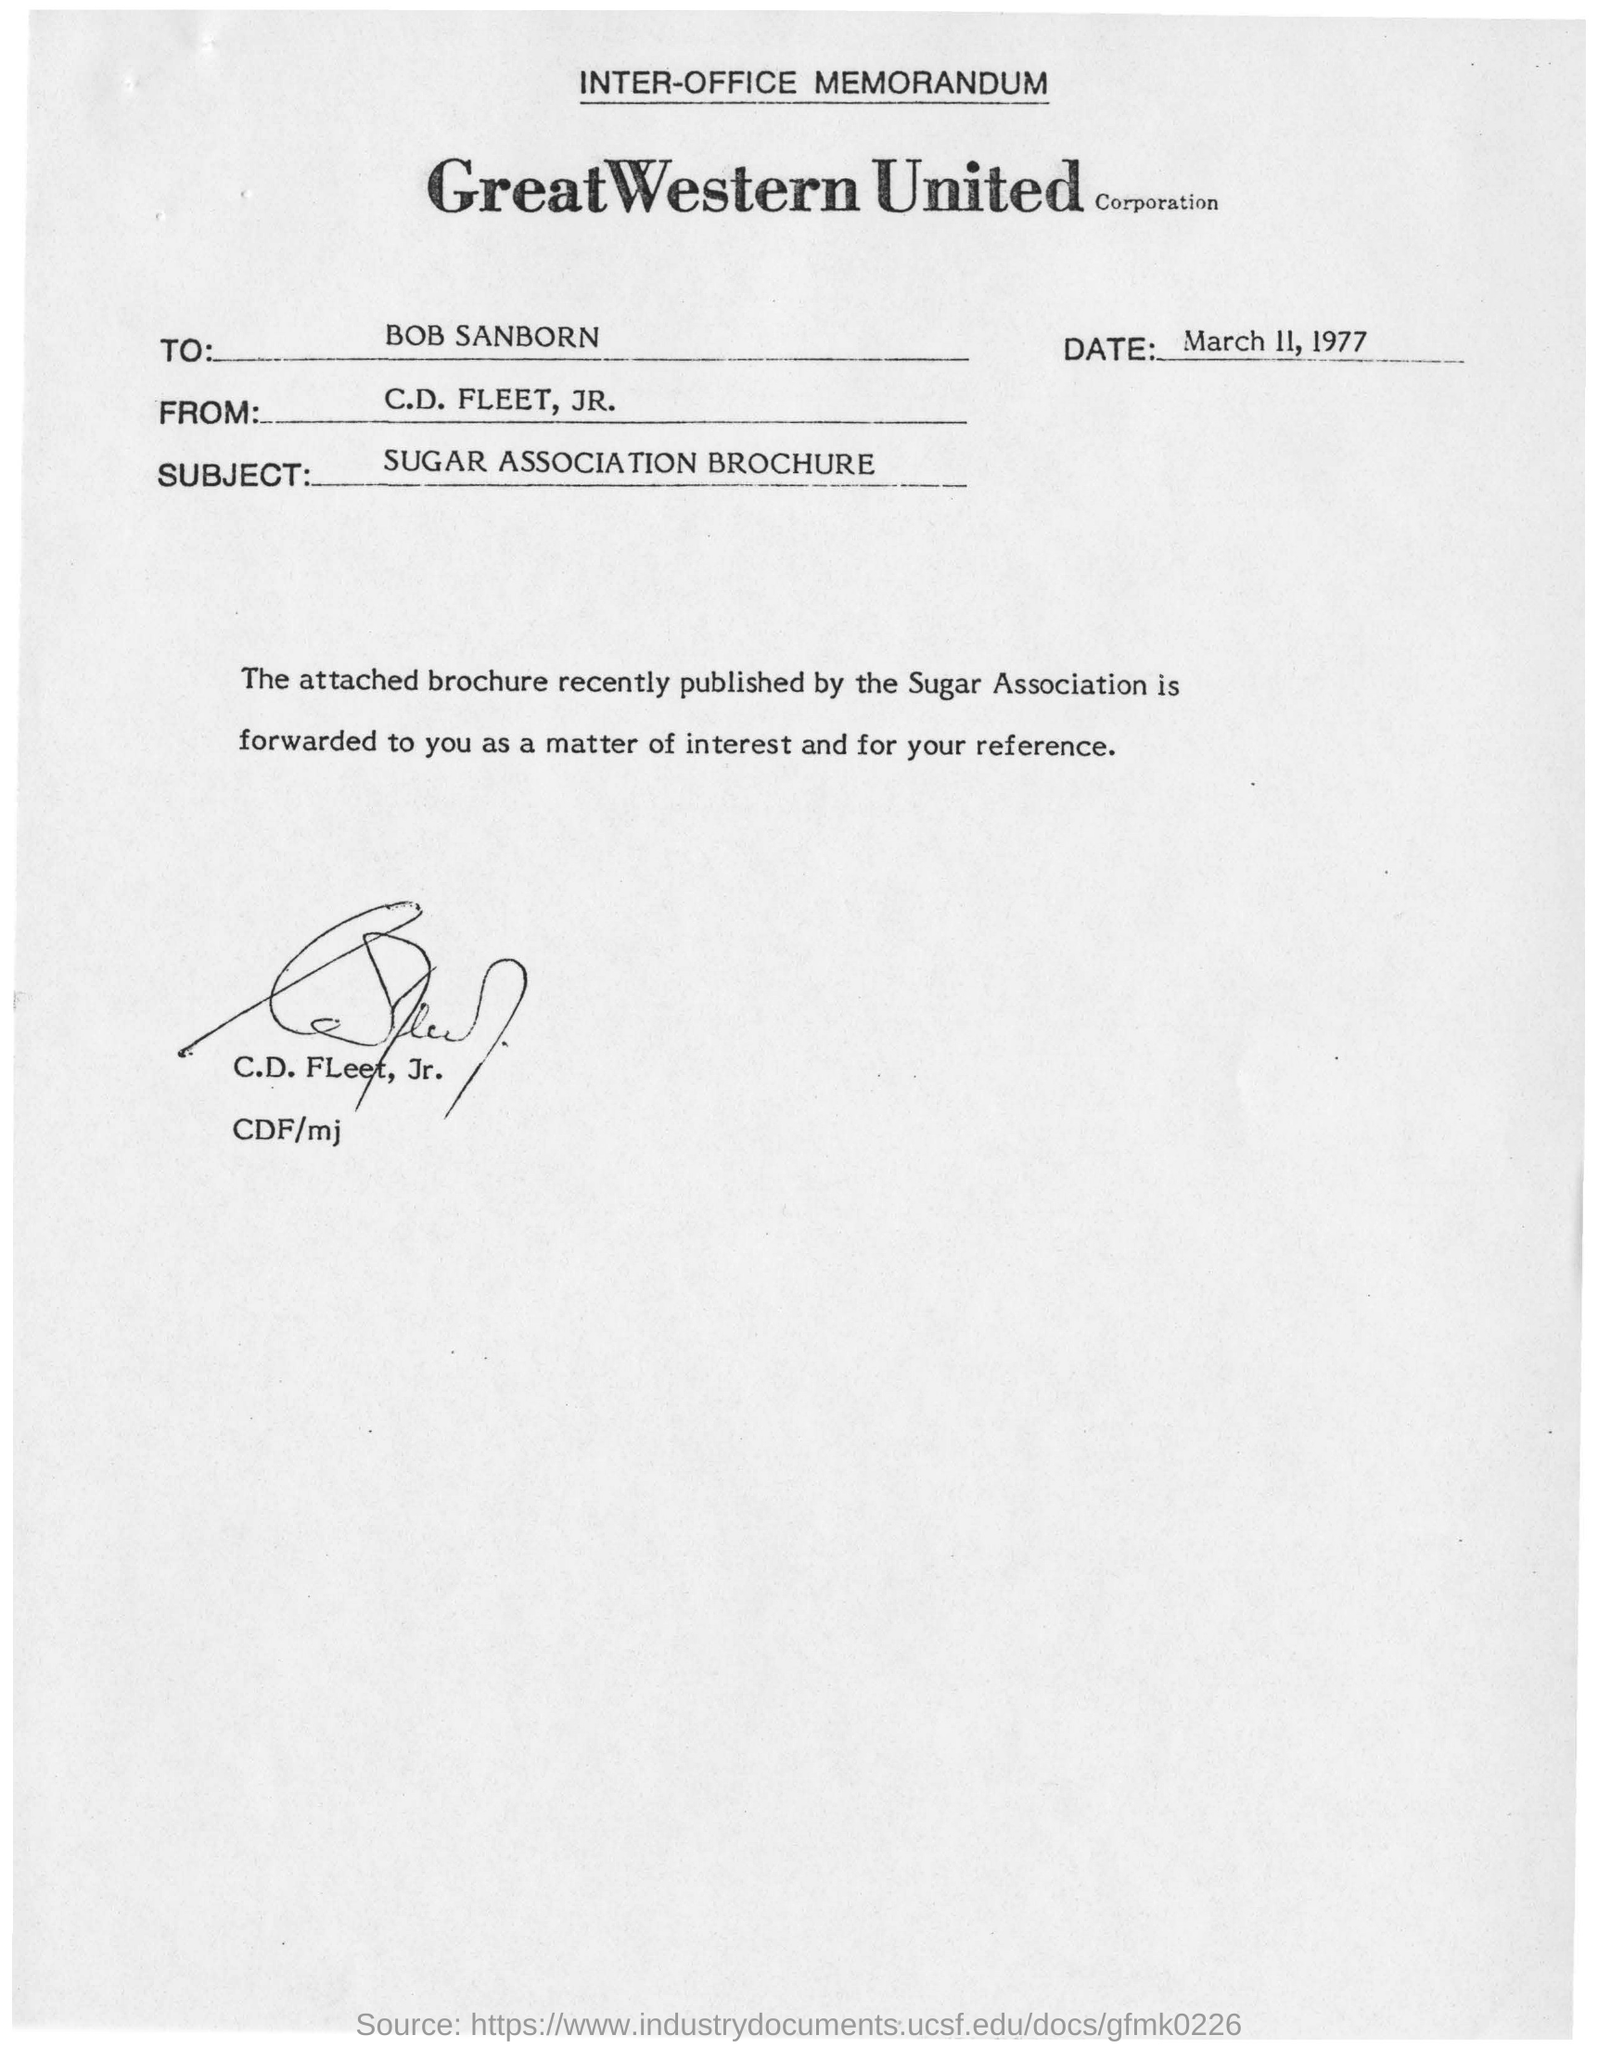Give some essential details in this illustration. The letter is dated March 11, 1977. The subject of the memorandum is the SUGAR ASSOCIATION BROCHURE. To whom is this memorandum addressed to? 